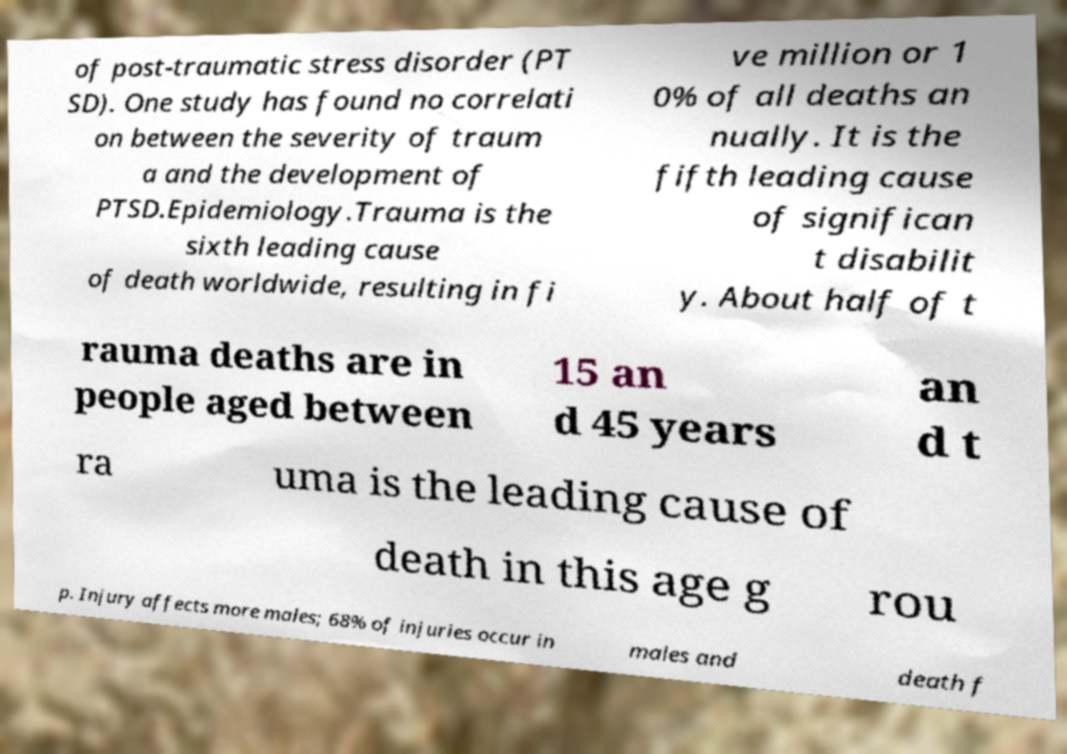Please identify and transcribe the text found in this image. of post-traumatic stress disorder (PT SD). One study has found no correlati on between the severity of traum a and the development of PTSD.Epidemiology.Trauma is the sixth leading cause of death worldwide, resulting in fi ve million or 1 0% of all deaths an nually. It is the fifth leading cause of significan t disabilit y. About half of t rauma deaths are in people aged between 15 an d 45 years an d t ra uma is the leading cause of death in this age g rou p. Injury affects more males; 68% of injuries occur in males and death f 